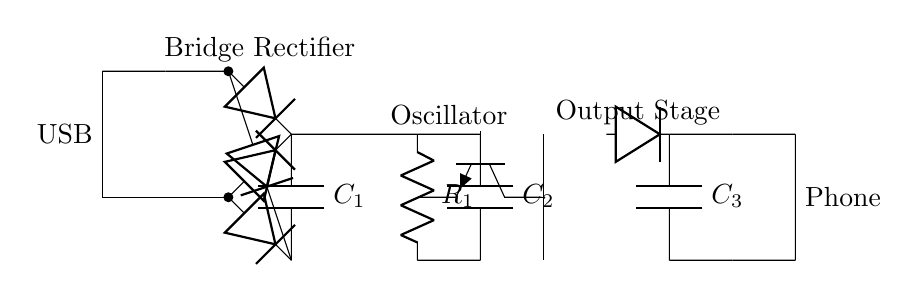What type of rectifier is used in this circuit? The circuit uses a bridge rectifier, identifiable by the arrangement of four diodes configured to convert AC to DC.
Answer: Bridge rectifier What does the smoothing capacitor (C1) do? The smoothing capacitor helps to reduce voltage ripples in the DC output from the rectifier, providing a more stable voltage level for the oscillator.
Answer: Reduces voltage ripples What frequency does the high-frequency switching oscillator typically operate at? This can vary, but commonly high-frequency oscillators in USB chargers operate in the range of tens to hundreds of kilohertz.
Answer: Tens to hundreds of kilohertz How many output capacitors are present in this circuit? There are two output capacitors, labeled C2 and C3. They are used for filtering and smoothing the output voltage.
Answer: Two What is the role of the transformer in this circuit? The transformer steps down or isolates the voltage, depending on its winding configuration, which is crucial for transferring power efficiently.
Answer: Steps down or isolates voltage How many diodes are used in the output stage? There is one diode in the output stage, which is part of the output rectification and filtering process.
Answer: One What happens to the voltage after passing through C3? After passing through C3, the voltage is further smoothed to provide a stable DC output for charging the phone.
Answer: Provides stable DC output 